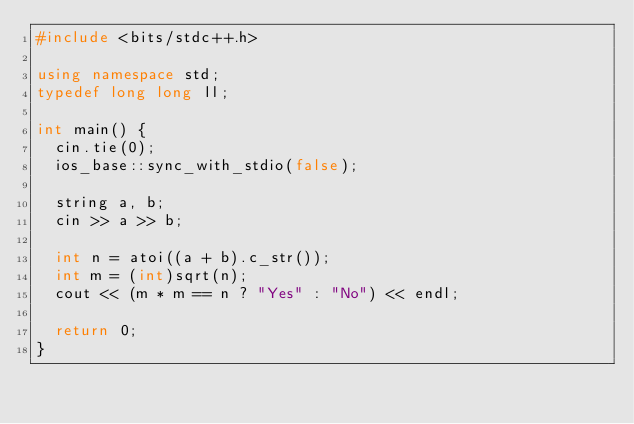Convert code to text. <code><loc_0><loc_0><loc_500><loc_500><_C++_>#include <bits/stdc++.h>

using namespace std;
typedef long long ll;

int main() {
  cin.tie(0);
  ios_base::sync_with_stdio(false);
  
  string a, b;
  cin >> a >> b;

  int n = atoi((a + b).c_str());
  int m = (int)sqrt(n);
  cout << (m * m == n ? "Yes" : "No") << endl;

  return 0;
}</code> 